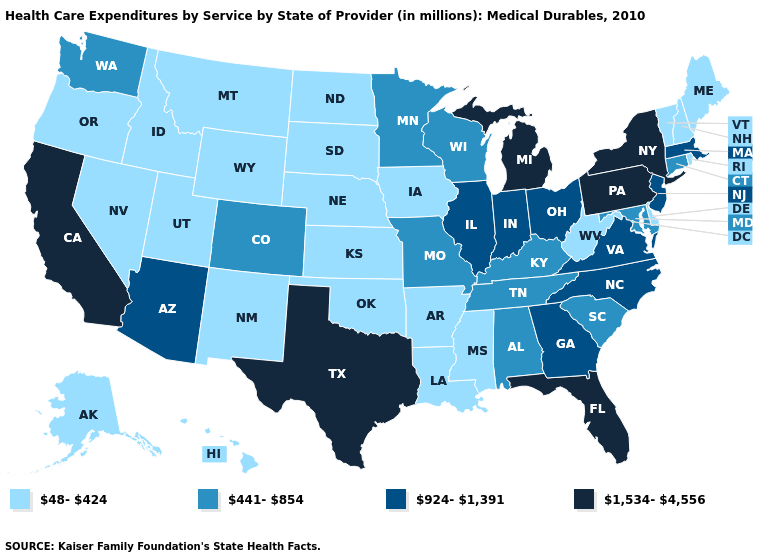What is the highest value in the USA?
Quick response, please. 1,534-4,556. Does Massachusetts have the lowest value in the Northeast?
Short answer required. No. Name the states that have a value in the range 441-854?
Answer briefly. Alabama, Colorado, Connecticut, Kentucky, Maryland, Minnesota, Missouri, South Carolina, Tennessee, Washington, Wisconsin. What is the value of Arizona?
Answer briefly. 924-1,391. Name the states that have a value in the range 1,534-4,556?
Short answer required. California, Florida, Michigan, New York, Pennsylvania, Texas. Among the states that border Indiana , which have the highest value?
Give a very brief answer. Michigan. Name the states that have a value in the range 924-1,391?
Write a very short answer. Arizona, Georgia, Illinois, Indiana, Massachusetts, New Jersey, North Carolina, Ohio, Virginia. What is the value of Oregon?
Short answer required. 48-424. What is the lowest value in states that border Illinois?
Answer briefly. 48-424. Does the map have missing data?
Write a very short answer. No. Does California have a higher value than Pennsylvania?
Keep it brief. No. What is the value of Hawaii?
Answer briefly. 48-424. Does Michigan have the lowest value in the MidWest?
Be succinct. No. What is the value of California?
Write a very short answer. 1,534-4,556. 